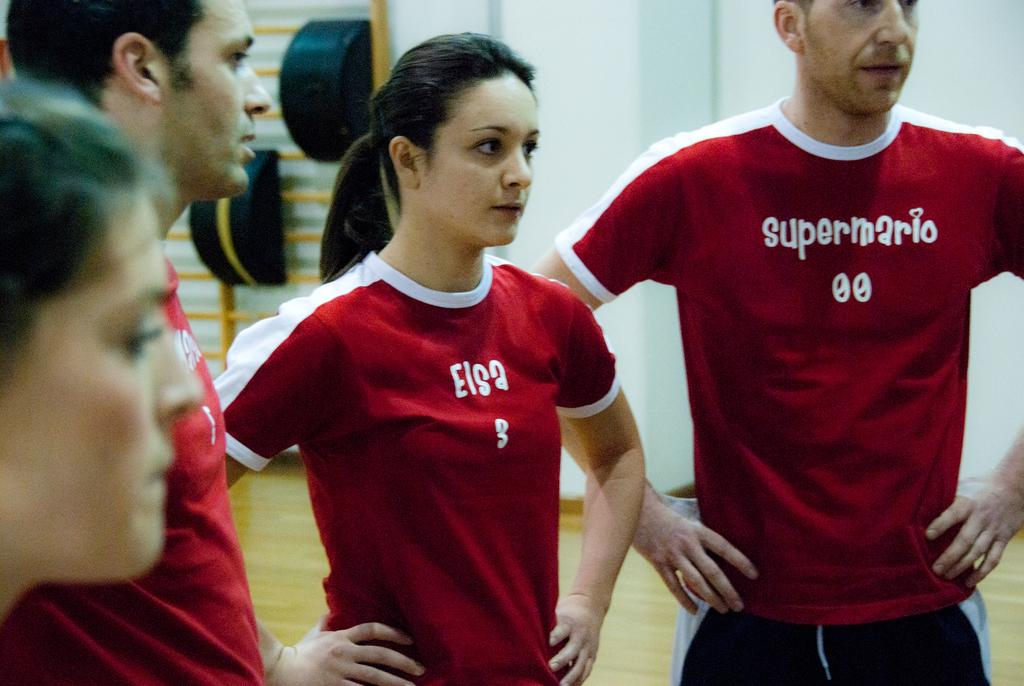<image>
Relay a brief, clear account of the picture shown. Two people standing next to one another with a shirt that says "Elsa". 